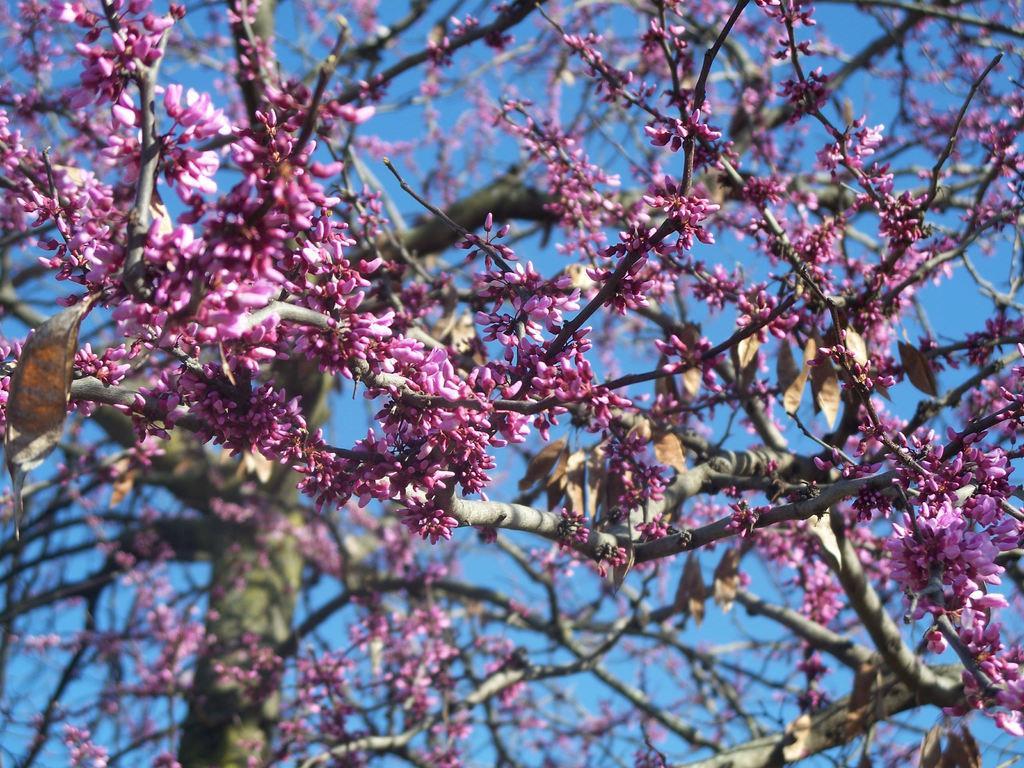Could you give a brief overview of what you see in this image? In the picture we can see a part of the tree with pink color flowers and from the tree we can see a part of the sky. 